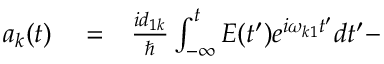<formula> <loc_0><loc_0><loc_500><loc_500>\begin{array} { r l r } { a _ { k } ( t ) } & = } & { \frac { i d _ { 1 k } } { } \int _ { - \infty } ^ { t } E ( t ^ { \prime } ) e ^ { i \omega _ { k 1 } t ^ { \prime } } d t ^ { \prime } - } \end{array}</formula> 